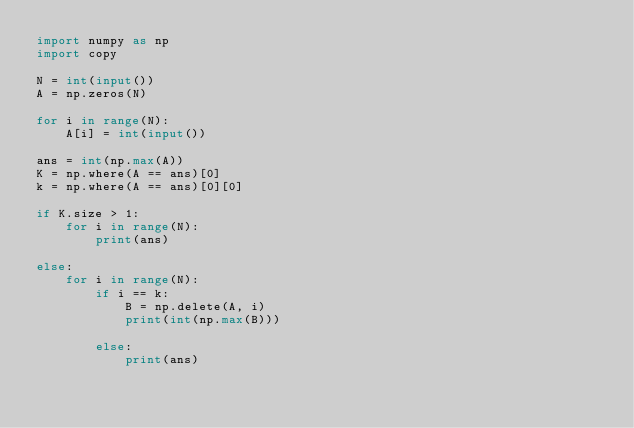Convert code to text. <code><loc_0><loc_0><loc_500><loc_500><_Python_>import numpy as np
import copy
  
N = int(input())  
A = np.zeros(N)

for i in range(N):
    A[i] = int(input())

ans = int(np.max(A))
K = np.where(A == ans)[0]
k = np.where(A == ans)[0][0]

if K.size > 1:
    for i in range(N):
        print(ans)
        
else:
    for i in range(N):
        if i == k:
            B = np.delete(A, i)
            print(int(np.max(B)))
    
        else:
            print(ans)</code> 